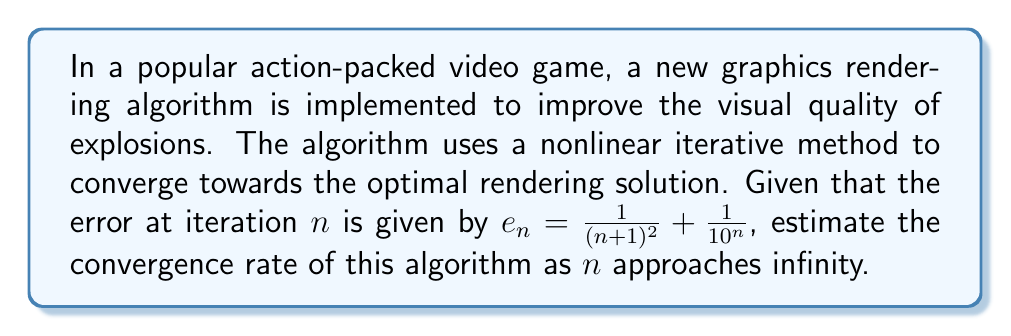Can you solve this math problem? Let's approach this step-by-step:

1) The convergence rate is determined by how quickly the error approaches zero as $n$ increases.

2) We have two terms in our error function:
   $$e_n = \frac{1}{(n+1)^2} + \frac{1}{10^n}$$

3) Let's examine each term separately as $n \to \infty$:

   a) For $\frac{1}{(n+1)^2}$:
      This term decreases quadratically, i.e., $O(n^{-2})$.

   b) For $\frac{1}{10^n}$:
      This term decreases exponentially, i.e., $O(10^{-n})$.

4) As $n \to \infty$, the exponential term $\frac{1}{10^n}$ will decrease much faster than the quadratic term $\frac{1}{(n+1)^2}$.

5) Therefore, for large $n$, the quadratic term will dominate the error:
   $$e_n \approx \frac{1}{(n+1)^2}$$

6) To estimate the convergence rate, we can use the ratio of consecutive errors:
   $$\lim_{n \to \infty} \frac{e_{n+1}}{e_n} = \lim_{n \to \infty} \frac{(\frac{1}{(n+2)^2})}{(\frac{1}{(n+1)^2})} = \lim_{n \to \infty} (\frac{n+1}{n+2})^2$$

7) Evaluating this limit:
   $$\lim_{n \to \infty} (\frac{n+1}{n+2})^2 = (1)^2 = 1$$

8) The convergence rate is $1$, which indicates linear convergence.
Answer: Linear convergence with rate 1 